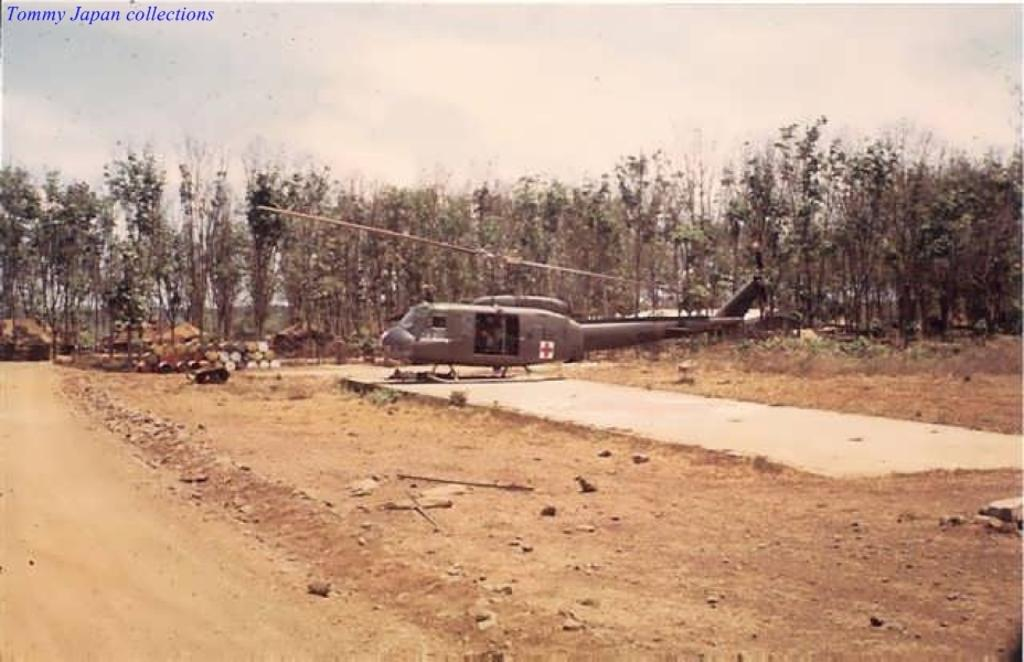What type of vehicle is on the ground in the image? There is a helicopter on the ground in the image. What can be seen in the image besides the helicopter? Trees are visible in the image. What is visible in the background of the image? The sky is visible in the background of the image. What is the condition of the sky in the image? Clouds are present in the sky. What type of tooth is visible in the image? There is no tooth present in the image. What experience can be gained from the helicopter in the image? The image does not convey any specific experience related to the helicopter; it simply shows the helicopter on the ground. 